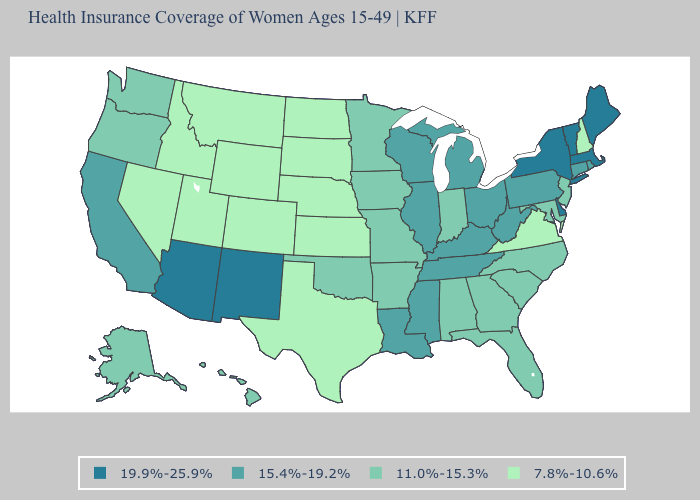Does the map have missing data?
Short answer required. No. Does New Hampshire have the lowest value in the Northeast?
Be succinct. Yes. How many symbols are there in the legend?
Write a very short answer. 4. Among the states that border California , does Nevada have the lowest value?
Quick response, please. Yes. Is the legend a continuous bar?
Keep it brief. No. Does California have the highest value in the West?
Quick response, please. No. What is the value of Idaho?
Write a very short answer. 7.8%-10.6%. What is the value of Rhode Island?
Give a very brief answer. 15.4%-19.2%. Is the legend a continuous bar?
Write a very short answer. No. What is the highest value in the Northeast ?
Quick response, please. 19.9%-25.9%. Does the map have missing data?
Keep it brief. No. Name the states that have a value in the range 11.0%-15.3%?
Quick response, please. Alabama, Alaska, Arkansas, Florida, Georgia, Hawaii, Indiana, Iowa, Maryland, Minnesota, Missouri, New Jersey, North Carolina, Oklahoma, Oregon, South Carolina, Washington. Which states have the lowest value in the USA?
Concise answer only. Colorado, Idaho, Kansas, Montana, Nebraska, Nevada, New Hampshire, North Dakota, South Dakota, Texas, Utah, Virginia, Wyoming. Does Georgia have the highest value in the South?
Quick response, please. No. What is the value of Utah?
Concise answer only. 7.8%-10.6%. 